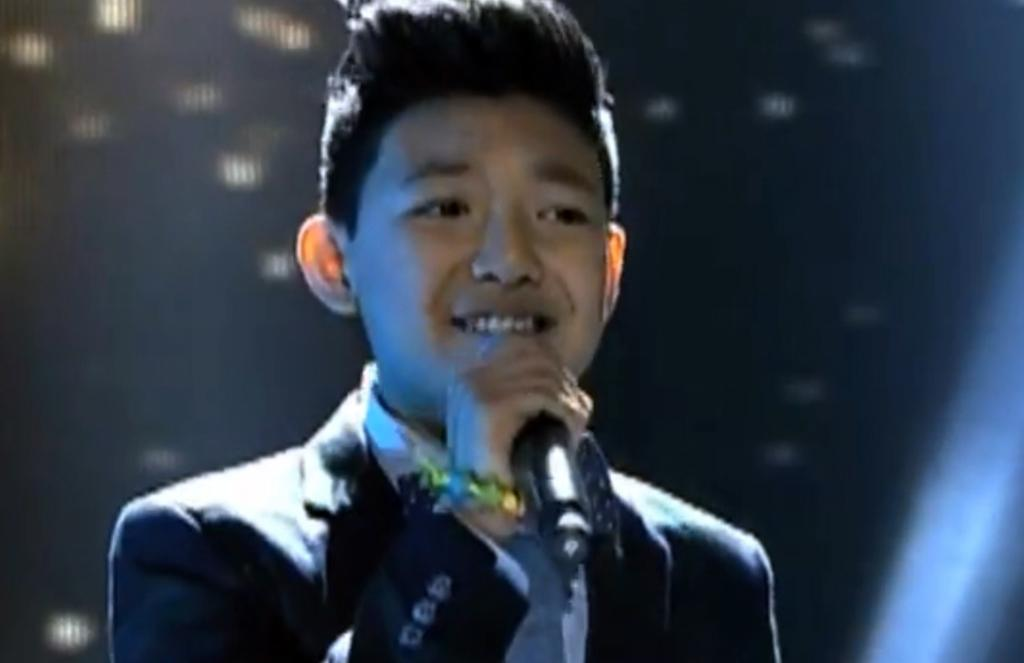Who is the main subject in the image? There is a boy in the image. What is the boy wearing? The boy is wearing a black suit. What object is the boy holding in the image? The boy is holding a microphone. What can be seen in the background of the image? There is a screen in the background of the image. What activity does the boy appear to be engaged in? The boy appears to be singing. What type of cup is the boy holding in the image? There is no cup present in the image; the boy is holding a microphone. How many cakes are visible on the screen in the background? There are no cakes visible on the screen in the background; only a screen is mentioned. 